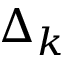<formula> <loc_0><loc_0><loc_500><loc_500>\Delta _ { k }</formula> 